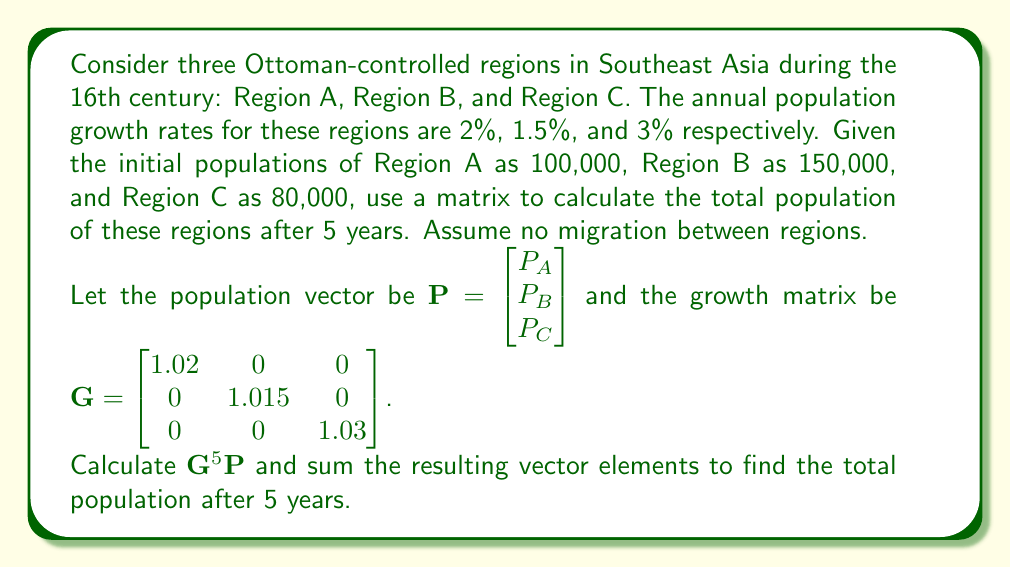Help me with this question. To solve this problem, we'll follow these steps:

1) First, let's set up our initial population vector:

   $\mathbf{P} = \begin{bmatrix} 100,000 \\ 150,000 \\ 80,000 \end{bmatrix}$

2) Our growth matrix $\mathbf{G}$ is already given:

   $\mathbf{G} = \begin{bmatrix} 1.02 & 0 & 0 \\ 0 & 1.015 & 0 \\ 0 & 0 & 1.03 \end{bmatrix}$

3) We need to calculate $\mathbf{G}^5$. Since $\mathbf{G}$ is a diagonal matrix, we can simply raise each element to the 5th power:

   $\mathbf{G}^5 = \begin{bmatrix} 1.02^5 & 0 & 0 \\ 0 & 1.015^5 & 0 \\ 0 & 0 & 1.03^5 \end{bmatrix}$

4) Calculate the values:
   
   $1.02^5 = 1.1041$
   $1.015^5 = 1.0769$
   $1.03^5 = 1.1593$

   So, $\mathbf{G}^5 = \begin{bmatrix} 1.1041 & 0 & 0 \\ 0 & 1.0769 & 0 \\ 0 & 0 & 1.1593 \end{bmatrix}$

5) Now, multiply $\mathbf{G}^5$ by $\mathbf{P}$:

   $\mathbf{G}^5 \mathbf{P} = \begin{bmatrix} 1.1041 & 0 & 0 \\ 0 & 1.0769 & 0 \\ 0 & 0 & 1.1593 \end{bmatrix} \begin{bmatrix} 100,000 \\ 150,000 \\ 80,000 \end{bmatrix}$

6) Perform the matrix multiplication:

   $\mathbf{G}^5 \mathbf{P} = \begin{bmatrix} 110,410 \\ 161,535 \\ 92,744 \end{bmatrix}$

7) Sum the elements of the resulting vector:

   $110,410 + 161,535 + 92,744 = 364,689$

Therefore, the total population after 5 years is 364,689.
Answer: 364,689 